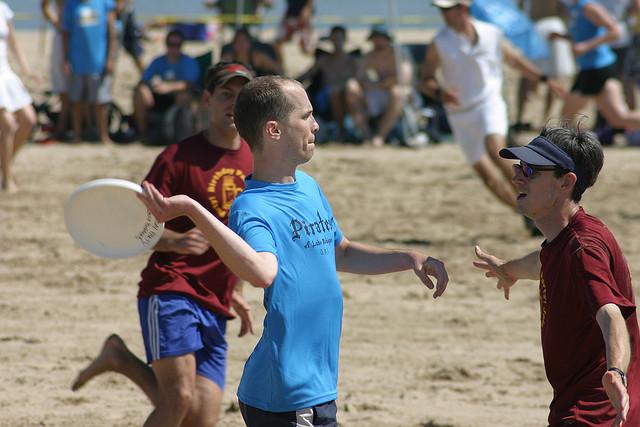Where is the frisbee?
Keep it brief. In man's hand. How many hats do you see?
Write a very short answer. 3. Are two guys trying to catch the frisbee?
Quick response, please. No. What is the man wearing?
Be succinct. Shirt. What sport are these men playing?
Short answer required. Frisbee. 